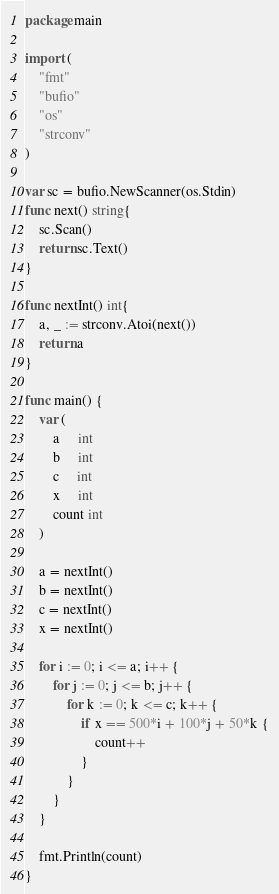Convert code to text. <code><loc_0><loc_0><loc_500><loc_500><_Go_>package main

import (
    "fmt"
    "bufio"
    "os"
    "strconv"
)

var sc = bufio.NewScanner(os.Stdin)
func next() string{
    sc.Scan()
    return sc.Text()
}

func nextInt() int{
    a, _ := strconv.Atoi(next())
    return a
}

func main() {
    var (
        a     int
        b     int
        c     int
        x     int
        count int
    )

    a = nextInt()
    b = nextInt()
    c = nextInt()
    x = nextInt()

    for i := 0; i <= a; i++ {
        for j := 0; j <= b; j++ {
            for k := 0; k <= c; k++ {
                if x == 500*i + 100*j + 50*k {
                    count++
                }
            }
        }
    }

    fmt.Println(count)
}</code> 